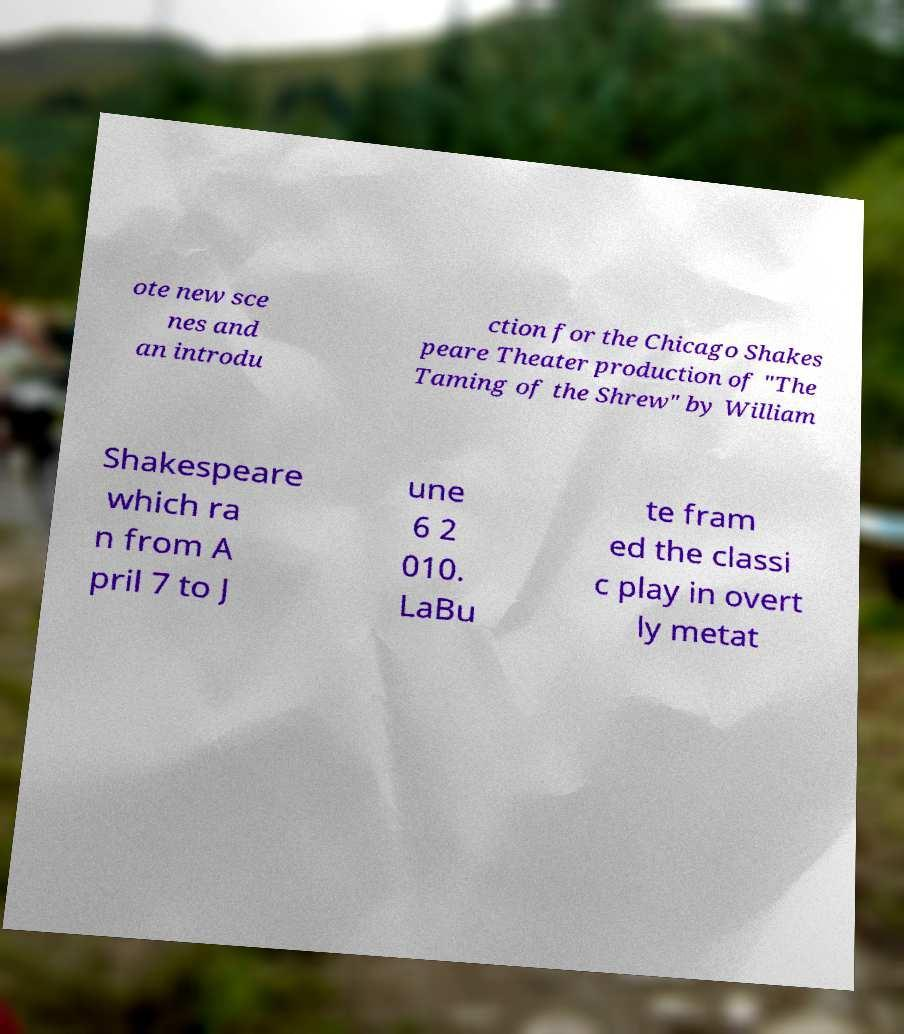For documentation purposes, I need the text within this image transcribed. Could you provide that? ote new sce nes and an introdu ction for the Chicago Shakes peare Theater production of "The Taming of the Shrew" by William Shakespeare which ra n from A pril 7 to J une 6 2 010. LaBu te fram ed the classi c play in overt ly metat 